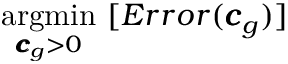Convert formula to latex. <formula><loc_0><loc_0><loc_500><loc_500>\underset { { \pm b { c } } _ { g } > 0 } { \arg \min } \ [ E r r o r ( { \pm b { c } } _ { g } ) ]</formula> 